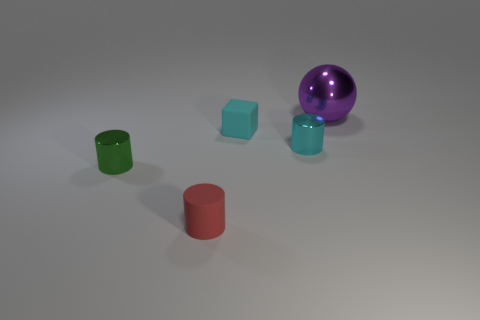What number of spheres are tiny cyan metallic objects or metallic things?
Your answer should be compact. 1. Do the purple shiny thing and the metallic object in front of the cyan shiny object have the same shape?
Keep it short and to the point. No. There is a shiny thing that is both right of the small cyan rubber block and in front of the cyan rubber block; what size is it?
Make the answer very short. Small. The green thing is what shape?
Offer a terse response. Cylinder. Is there a small cyan block that is to the left of the tiny metal cylinder on the right side of the tiny cyan matte thing?
Give a very brief answer. Yes. There is a metal cylinder that is left of the cyan metallic object; what number of things are left of it?
Your response must be concise. 0. What material is the cyan cylinder that is the same size as the cyan rubber cube?
Provide a succinct answer. Metal. There is a rubber thing in front of the green cylinder; does it have the same shape as the small cyan rubber object?
Provide a succinct answer. No. Is the number of tiny cubes on the right side of the large metal ball greater than the number of cyan metal cylinders that are in front of the cyan shiny object?
Offer a terse response. No. What number of large purple spheres have the same material as the cyan cylinder?
Offer a terse response. 1. 